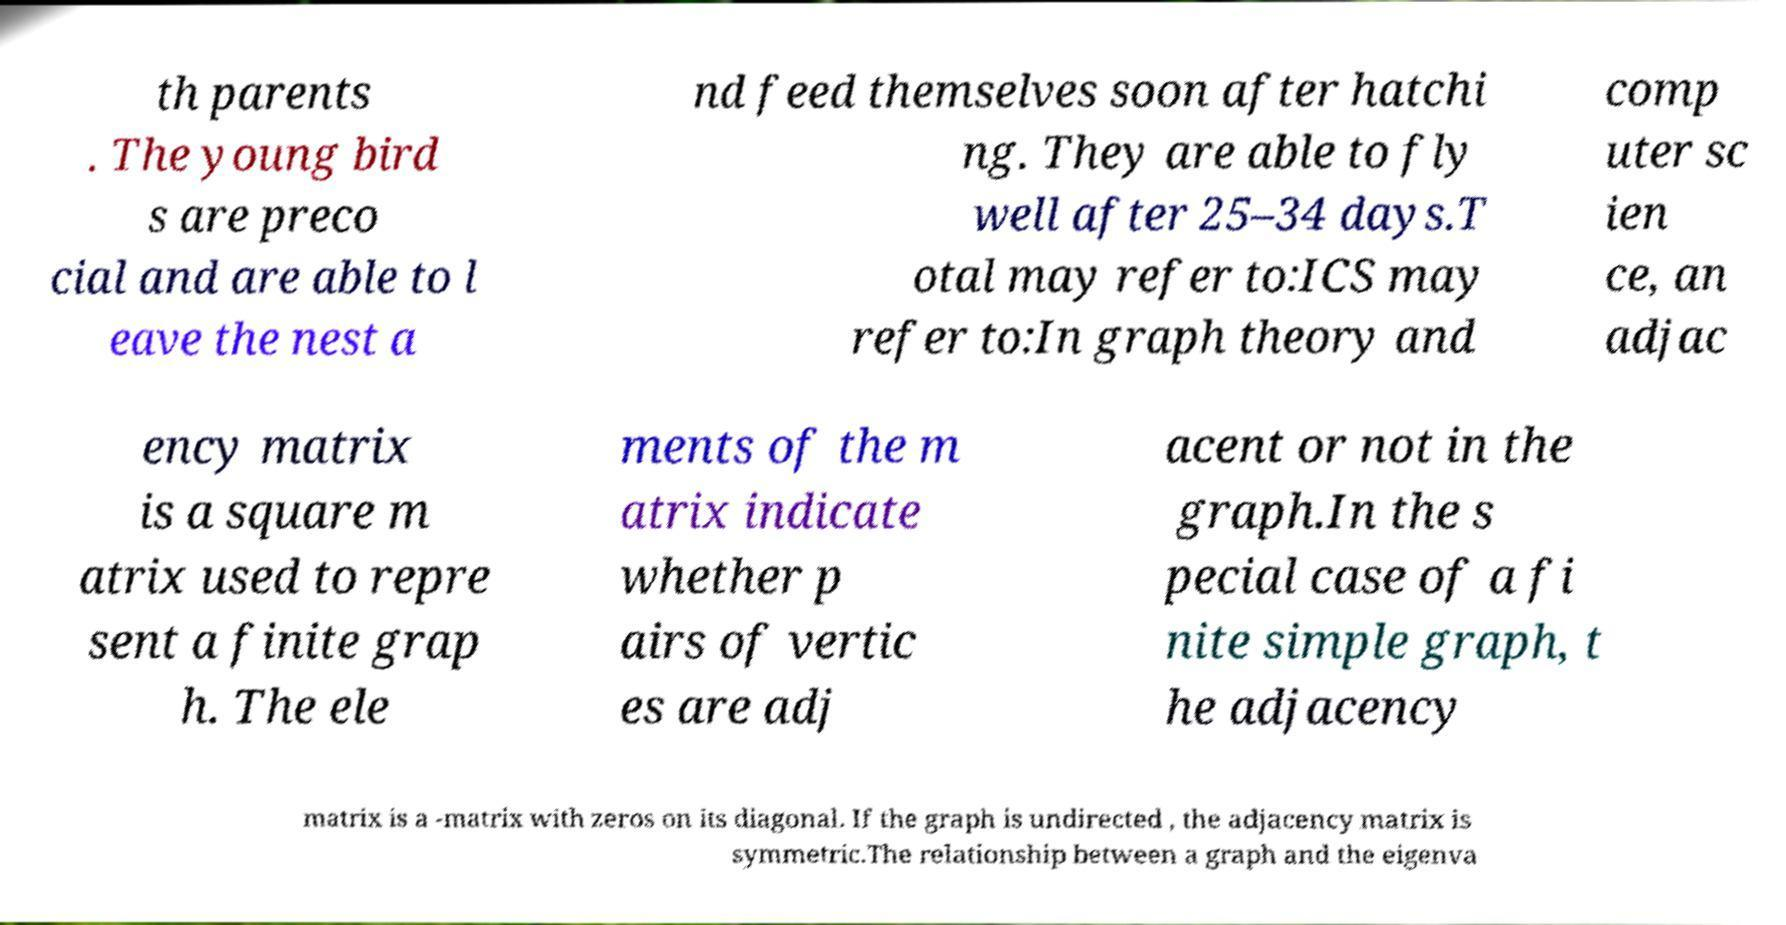What messages or text are displayed in this image? I need them in a readable, typed format. th parents . The young bird s are preco cial and are able to l eave the nest a nd feed themselves soon after hatchi ng. They are able to fly well after 25–34 days.T otal may refer to:ICS may refer to:In graph theory and comp uter sc ien ce, an adjac ency matrix is a square m atrix used to repre sent a finite grap h. The ele ments of the m atrix indicate whether p airs of vertic es are adj acent or not in the graph.In the s pecial case of a fi nite simple graph, t he adjacency matrix is a -matrix with zeros on its diagonal. If the graph is undirected , the adjacency matrix is symmetric.The relationship between a graph and the eigenva 